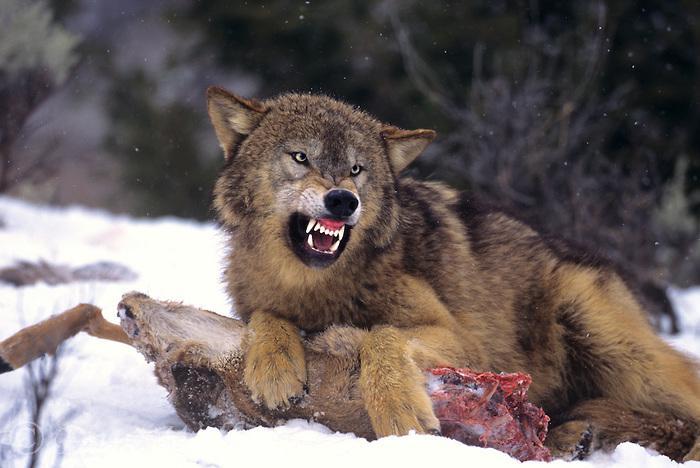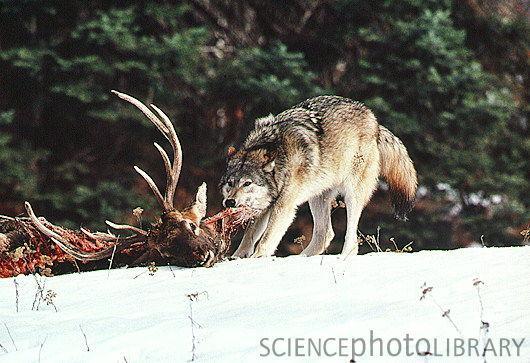The first image is the image on the left, the second image is the image on the right. For the images shown, is this caption "At least one wolf is hovering over dead prey." true? Answer yes or no. Yes. 